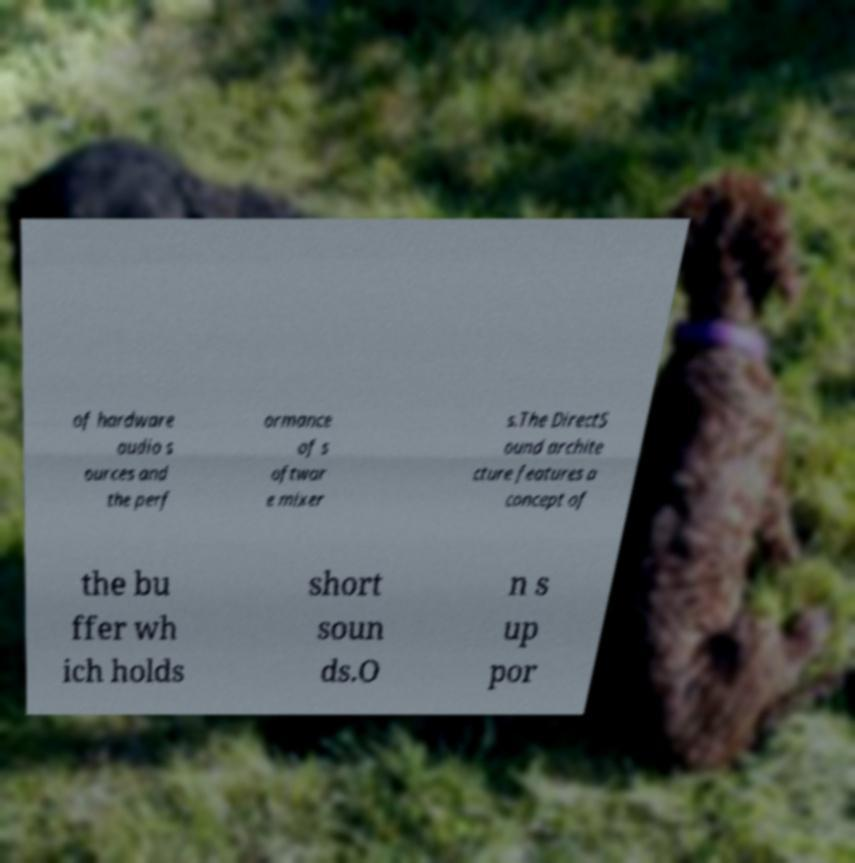What messages or text are displayed in this image? I need them in a readable, typed format. of hardware audio s ources and the perf ormance of s oftwar e mixer s.The DirectS ound archite cture features a concept of the bu ffer wh ich holds short soun ds.O n s up por 